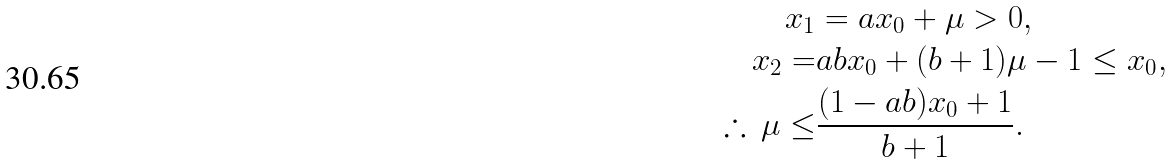<formula> <loc_0><loc_0><loc_500><loc_500>x _ { 1 } & = a x _ { 0 } + \mu > 0 , \\ x _ { 2 } = & a b x _ { 0 } + ( b + 1 ) \mu - 1 \leq x _ { 0 } , \\ \therefore \, \mu \leq & \frac { ( 1 - a b ) x _ { 0 } + 1 } { b + 1 } .</formula> 